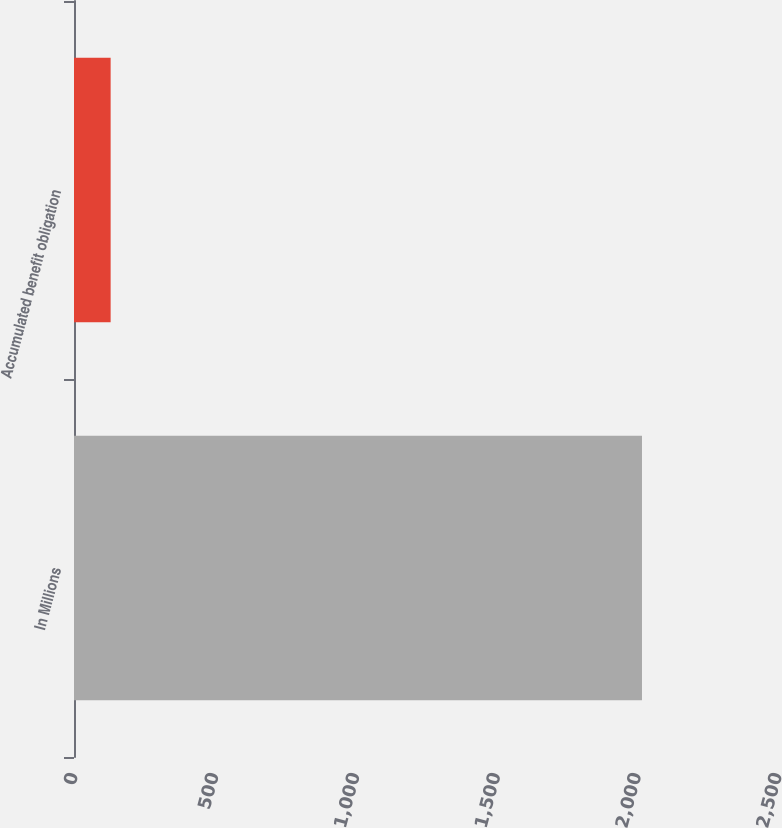<chart> <loc_0><loc_0><loc_500><loc_500><bar_chart><fcel>In Millions<fcel>Accumulated benefit obligation<nl><fcel>2017<fcel>130.1<nl></chart> 